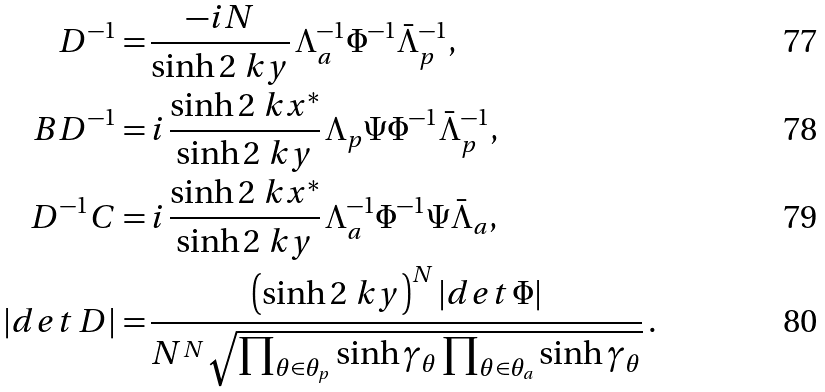Convert formula to latex. <formula><loc_0><loc_0><loc_500><loc_500>D ^ { - 1 } = & \, \frac { - i N } { \sinh 2 \ k y } \, \Lambda _ { a } ^ { - 1 } \Phi ^ { - 1 } \bar { \Lambda } _ { p } ^ { - 1 } , \\ B D ^ { - 1 } = & \, i \, \frac { \sinh 2 \ k x ^ { * } } { \sinh 2 \ k y } \, \Lambda _ { p } \Psi \Phi ^ { - 1 } \bar { \Lambda } _ { p } ^ { - 1 } , \\ D ^ { - 1 } C = & \, i \, \frac { \sinh 2 \ k x ^ { * } } { \sinh 2 \ k y } \, \Lambda _ { a } ^ { - 1 } \Phi ^ { - 1 } \Psi \bar { \Lambda } _ { a } , \\ | d e t \, D | = & \, \frac { \left ( \sinh 2 \ k y \right ) ^ { N } | d e t \, \Phi | } { N ^ { N } \sqrt { \prod _ { \theta \in \theta _ { p } } \sinh \gamma _ { \theta } \prod _ { \theta \in \theta _ { a } } \sinh \gamma _ { \theta } } } \, .</formula> 